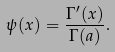<formula> <loc_0><loc_0><loc_500><loc_500>\psi ( x ) = \frac { \Gamma ^ { \prime } ( x ) } { \Gamma ( a ) } .</formula> 